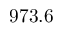<formula> <loc_0><loc_0><loc_500><loc_500>9 7 3 . 6</formula> 